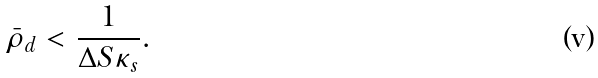<formula> <loc_0><loc_0><loc_500><loc_500>\bar { \rho } _ { d } < \frac { 1 } { \Delta S \kappa _ { s } } .</formula> 